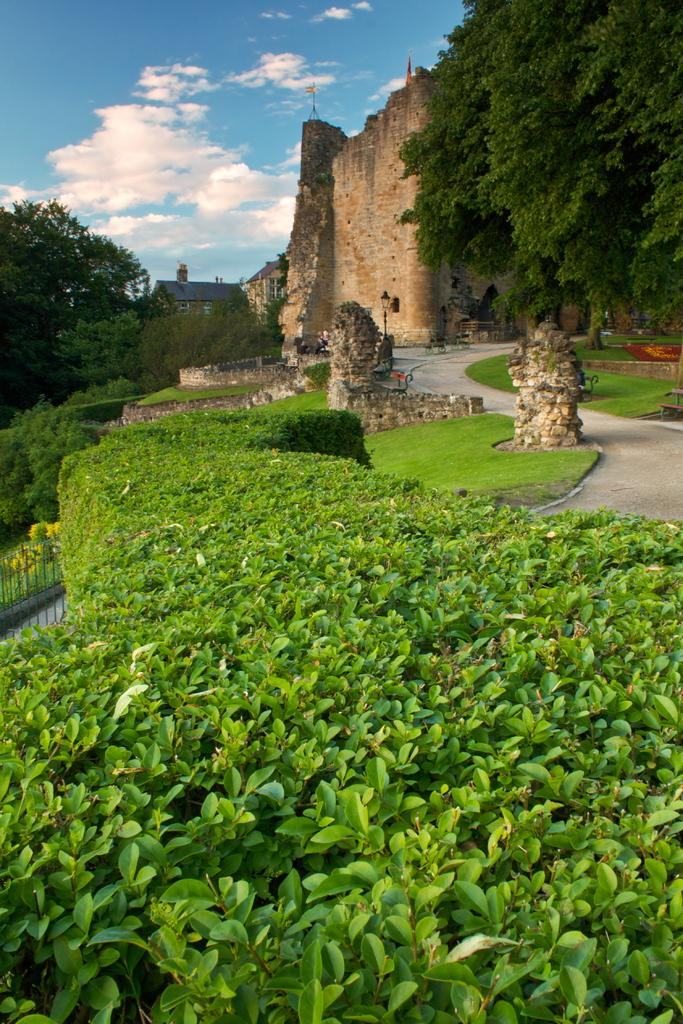What type of vegetation can be seen in the image? There is a group of plants, trees, and grass visible in the image. What type of structures are present in the image? There are walls, fencing, and houses in the image. What is visible at the top of the image? The sky is visible at the top of the image. How many stamps are on the houses in the image? There are no stamps present on the houses in the image. What type of trouble can be seen in the image? There is no trouble depicted in the image; it features plants, trees, grass, walls, fencing, houses, and the sky. 